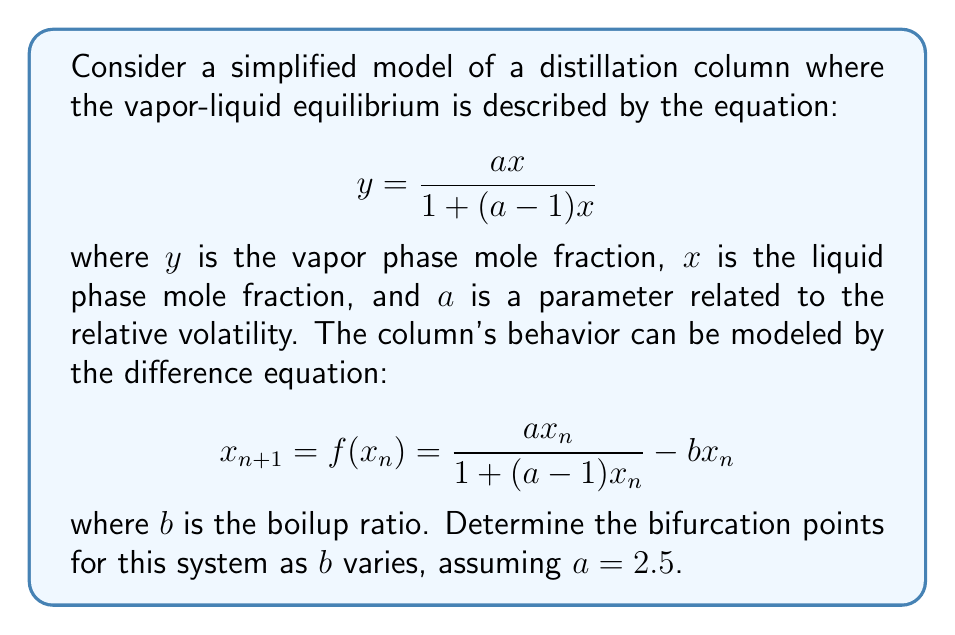Give your solution to this math problem. To find the bifurcation points, we need to follow these steps:

1) First, we find the fixed points of the system by solving the equation $x = f(x)$:

   $$x = \frac{ax}{1+(a-1)x} - bx$$

2) Rearranging this equation:

   $$x(1+(a-1)x) = ax - bx(1+(a-1)x)$$
   $$(1+b)x + (a-1)x^2 = ax - b(a-1)x^2$$
   $$(1+b)x + (a-1+b(a-1))x^2 = ax$$

3) Simplifying and collecting terms:

   $$ax^2(a-1+b(a-1)) - x(a-1-b) = 0$$
   $$x[ax(a-1+b(a-1)) - (a-1-b)] = 0$$

4) This equation has two solutions: $x=0$ and the solution of the quadratic equation:

   $$ax(a-1+b(a-1)) - (a-1-b) = 0$$

5) The bifurcation occurs when these two solutions coincide, i.e., when the quadratic equation has a double root. This happens when its discriminant is zero.

6) The general form of a quadratic equation is $Ax^2 + Bx + C = 0$. In our case:
   
   $A = a(a-1+b(a-1))$
   $B = -(a-1-b)$
   $C = 0$

7) The discriminant is given by $B^2 - 4AC = 0$. Substituting our values:

   $$(a-1-b)^2 - 4a(a-1+b(a-1)) \cdot 0 = 0$$

8) Simplifying:

   $$(a-1-b)^2 = 0$$

9) Solving this equation:

   $$a-1-b = 0$$
   $$b = a-1$$

10) Given $a=2.5$, we can calculate the bifurcation point:

    $$b = 2.5 - 1 = 1.5$$

Therefore, the system undergoes a bifurcation when $b = 1.5$.
Answer: $b = 1.5$ 